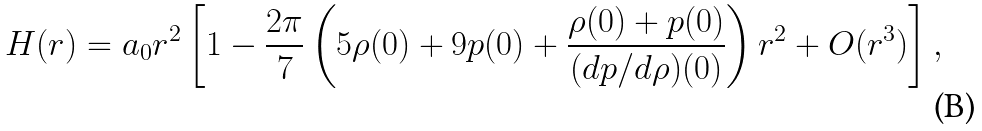<formula> <loc_0><loc_0><loc_500><loc_500>H ( r ) = a _ { 0 } r ^ { 2 } \left [ 1 - \frac { 2 \pi } { 7 } \left ( 5 \rho ( 0 ) + 9 p ( 0 ) + \frac { \rho ( 0 ) + p ( 0 ) } { ( d p / d \rho ) ( 0 ) } \right ) r ^ { 2 } + O ( r ^ { 3 } ) \right ] ,</formula> 